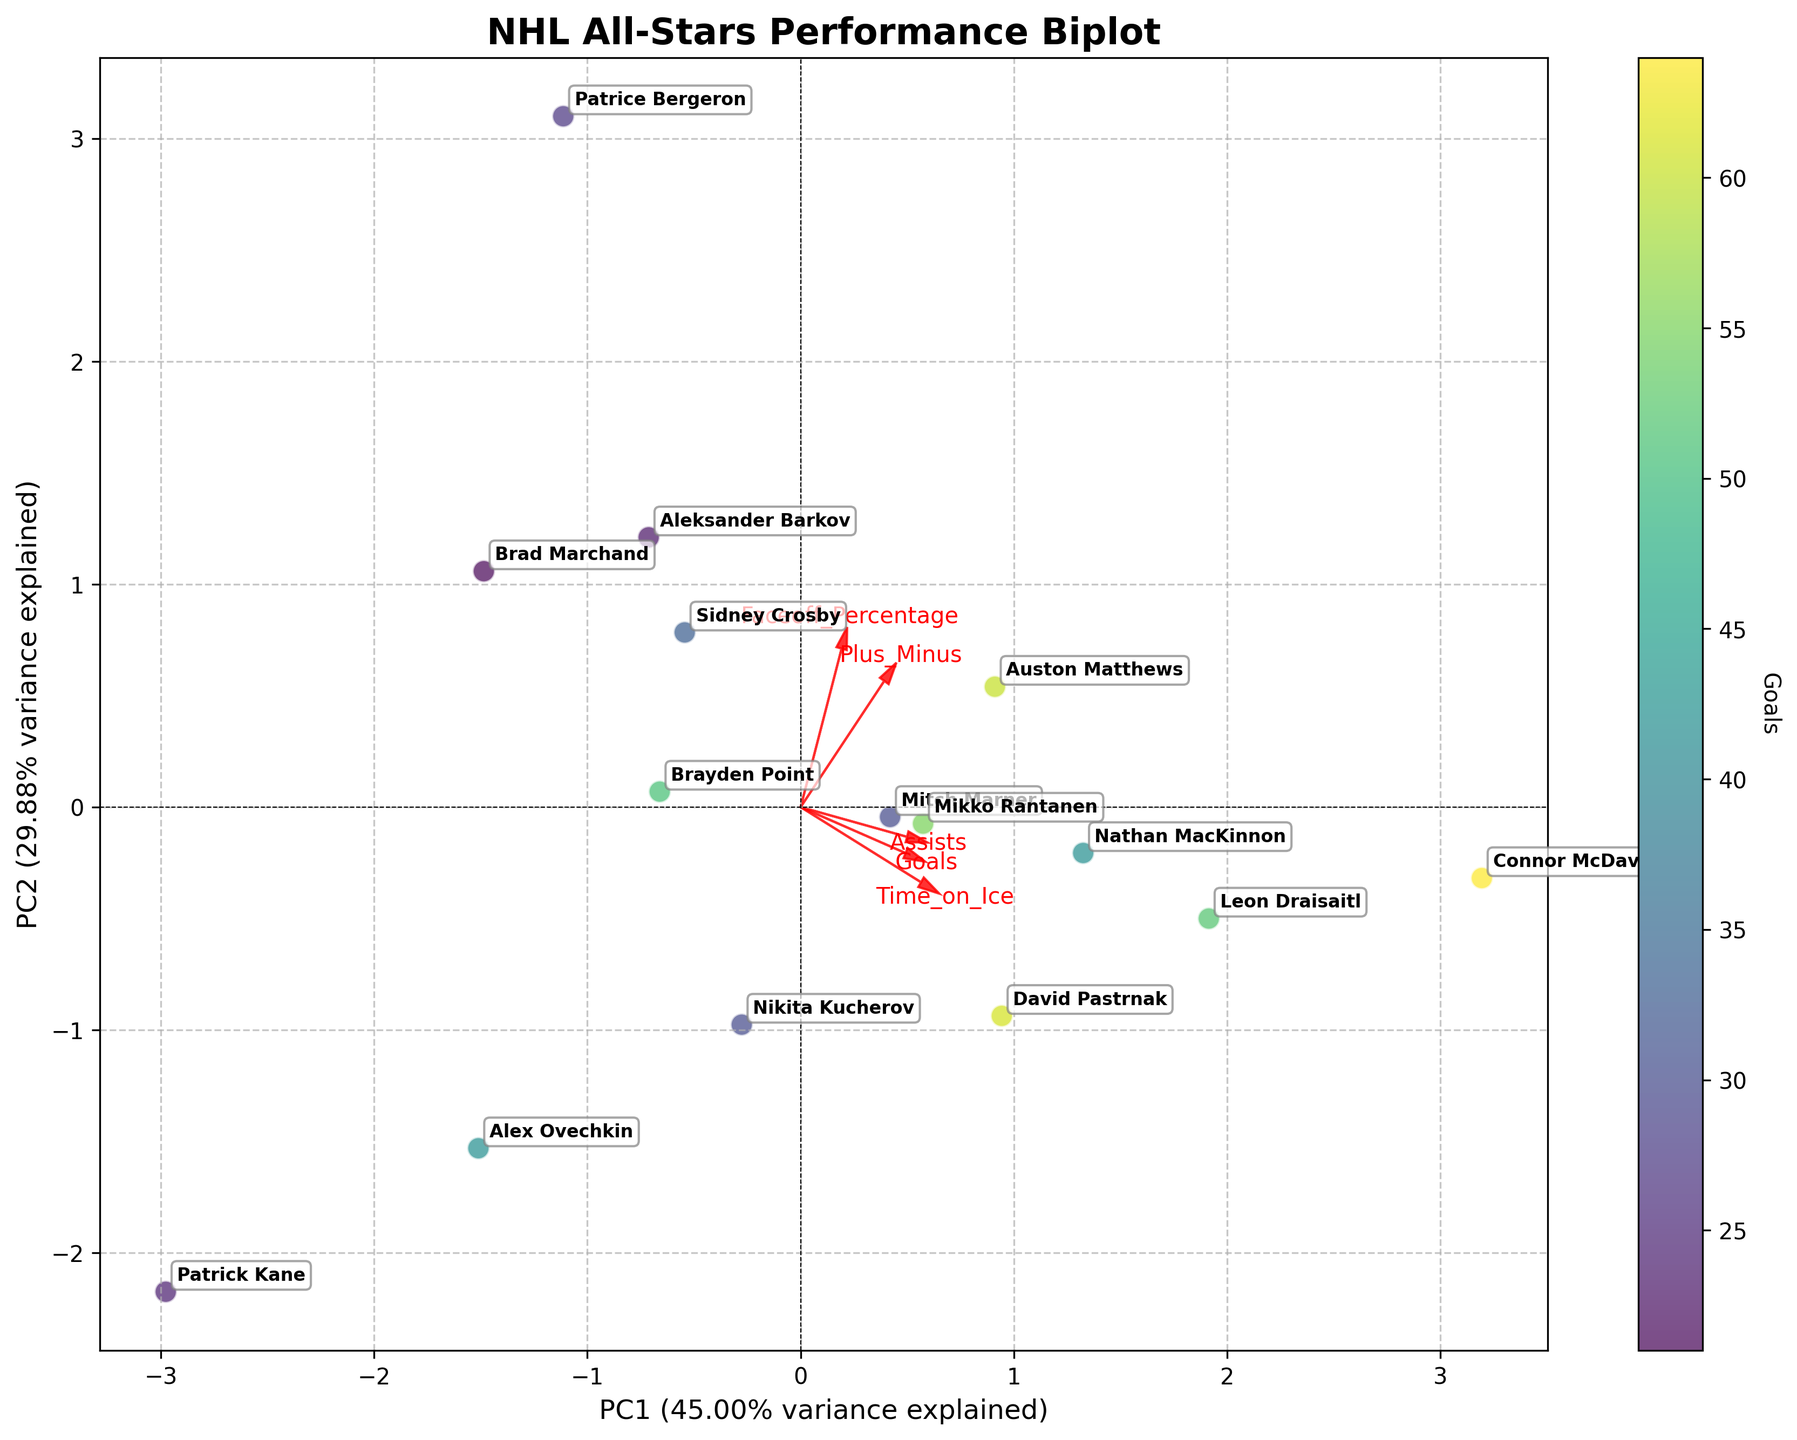How many player data points are represented in the plot? By counting the annotations (names) present in the biplot, we can see that there are as many data points as there are names shown.
Answer: 15 What is the title of the plot? The title is written at the top of the figure.
Answer: NHL All-Stars Performance Biplot Which player has the highest Goals variable in the plot? By looking at the color scale and finding the player associated with the darkest color, we can identify the player with the highest goals.
Answer: Connor McDavid Which players are closest together in the biplot? We need to look at the spatial distribution of the points and find pairs that are near each other.
Answer: Sidney Crosby and Brayden Point Which feature has the largest vector in the biplot? The length of the arrow (vector) in the biplot represents the contribution of each feature, and the longest arrow indicates the largest vector.
Answer: Time_on_Ice Which player is most associated with high values of Faceoff_Percentage? We should identify the direction of the Faceoff_Percentage arrow and look at points lying in that direction.
Answer: Patrice Bergeron Which two players have almost opposite performance metrics based on the biplot? By finding two points on opposite ends of the plot, we can determine which players have opposite metrics.
Answer: Patrick Kane and Patrice Bergeron What percentage of the total variance is explained by PC1 alone? The exact percentage is written on the x-axis label, next to "PC1".
Answer: 40.54% How does the Plus_Minus feature relate to the principal components? By examining the direction and length of the Plus_Minus arrow, we can assess its influence on the principal components.
Answer: It aligns moderately with both PC1 and PC2 Which feature seems to contribute least to the separation of players in the biplot? The shortest arrow among the feature vectors in the plot indicates the least contribution.
Answer: Faceoff_Percentage 